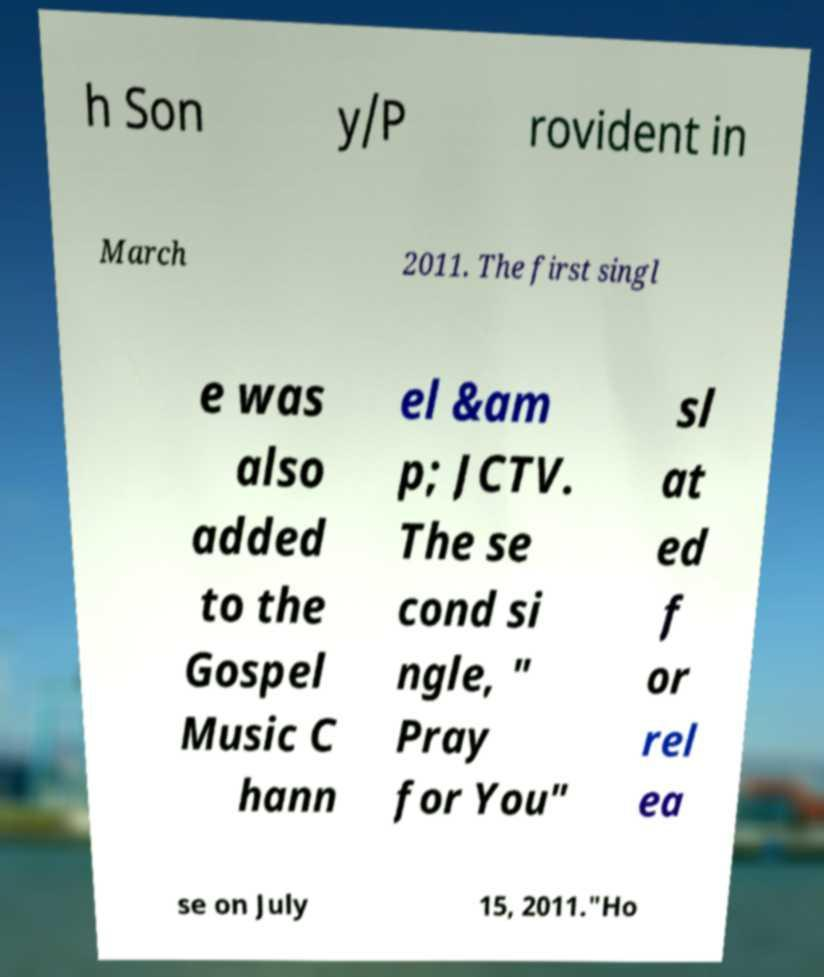For documentation purposes, I need the text within this image transcribed. Could you provide that? h Son y/P rovident in March 2011. The first singl e was also added to the Gospel Music C hann el &am p; JCTV. The se cond si ngle, " Pray for You" sl at ed f or rel ea se on July 15, 2011."Ho 